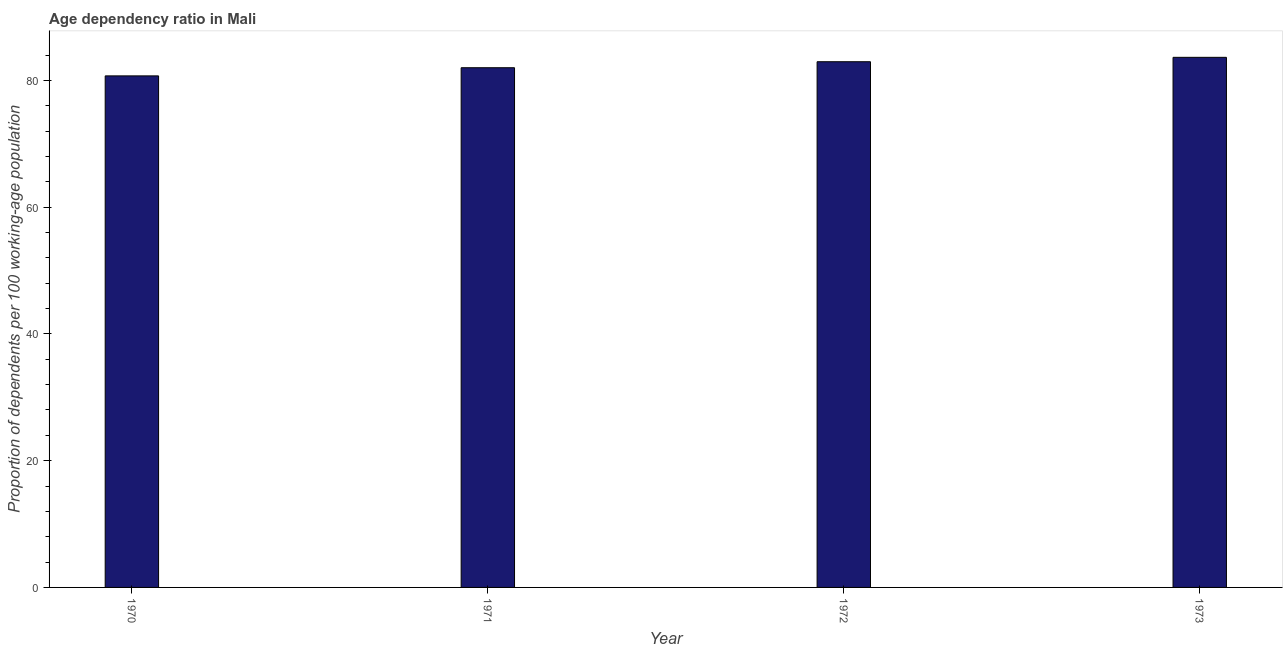Does the graph contain grids?
Keep it short and to the point. No. What is the title of the graph?
Your response must be concise. Age dependency ratio in Mali. What is the label or title of the Y-axis?
Offer a very short reply. Proportion of dependents per 100 working-age population. What is the age dependency ratio in 1970?
Ensure brevity in your answer.  80.71. Across all years, what is the maximum age dependency ratio?
Keep it short and to the point. 83.63. Across all years, what is the minimum age dependency ratio?
Keep it short and to the point. 80.71. In which year was the age dependency ratio maximum?
Keep it short and to the point. 1973. What is the sum of the age dependency ratio?
Keep it short and to the point. 329.27. What is the difference between the age dependency ratio in 1970 and 1973?
Offer a very short reply. -2.93. What is the average age dependency ratio per year?
Your answer should be very brief. 82.32. What is the median age dependency ratio?
Your response must be concise. 82.47. In how many years, is the age dependency ratio greater than 56 ?
Provide a short and direct response. 4. Is the age dependency ratio in 1971 less than that in 1972?
Keep it short and to the point. Yes. Is the difference between the age dependency ratio in 1972 and 1973 greater than the difference between any two years?
Make the answer very short. No. What is the difference between the highest and the second highest age dependency ratio?
Keep it short and to the point. 0.69. What is the difference between the highest and the lowest age dependency ratio?
Offer a very short reply. 2.93. In how many years, is the age dependency ratio greater than the average age dependency ratio taken over all years?
Provide a short and direct response. 2. What is the difference between two consecutive major ticks on the Y-axis?
Provide a short and direct response. 20. Are the values on the major ticks of Y-axis written in scientific E-notation?
Provide a short and direct response. No. What is the Proportion of dependents per 100 working-age population in 1970?
Make the answer very short. 80.71. What is the Proportion of dependents per 100 working-age population in 1971?
Make the answer very short. 81.99. What is the Proportion of dependents per 100 working-age population of 1972?
Offer a terse response. 82.94. What is the Proportion of dependents per 100 working-age population in 1973?
Your response must be concise. 83.63. What is the difference between the Proportion of dependents per 100 working-age population in 1970 and 1971?
Keep it short and to the point. -1.29. What is the difference between the Proportion of dependents per 100 working-age population in 1970 and 1972?
Ensure brevity in your answer.  -2.23. What is the difference between the Proportion of dependents per 100 working-age population in 1970 and 1973?
Your answer should be very brief. -2.93. What is the difference between the Proportion of dependents per 100 working-age population in 1971 and 1972?
Make the answer very short. -0.95. What is the difference between the Proportion of dependents per 100 working-age population in 1971 and 1973?
Offer a terse response. -1.64. What is the difference between the Proportion of dependents per 100 working-age population in 1972 and 1973?
Ensure brevity in your answer.  -0.69. What is the ratio of the Proportion of dependents per 100 working-age population in 1970 to that in 1973?
Offer a very short reply. 0.96. What is the ratio of the Proportion of dependents per 100 working-age population in 1971 to that in 1972?
Your answer should be compact. 0.99. What is the ratio of the Proportion of dependents per 100 working-age population in 1972 to that in 1973?
Offer a very short reply. 0.99. 